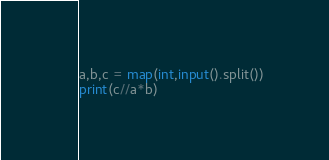<code> <loc_0><loc_0><loc_500><loc_500><_Python_>a,b,c = map(int,input().split())
print(c//a*b)</code> 